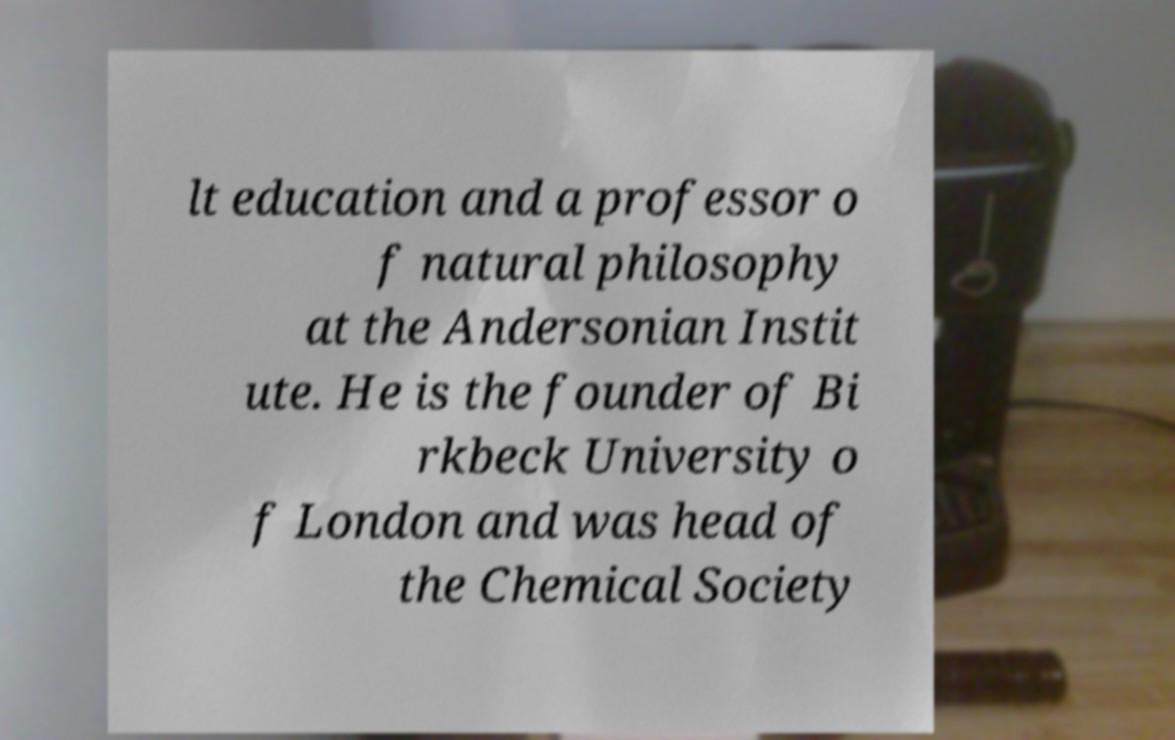I need the written content from this picture converted into text. Can you do that? lt education and a professor o f natural philosophy at the Andersonian Instit ute. He is the founder of Bi rkbeck University o f London and was head of the Chemical Society 